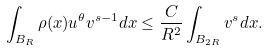Convert formula to latex. <formula><loc_0><loc_0><loc_500><loc_500>\int _ { B _ { R } } \rho ( x ) u ^ { \theta } v ^ { s - 1 } d x \leq \frac { C } { R ^ { 2 } } \int _ { B _ { 2 R } } v ^ { s } d x .</formula> 